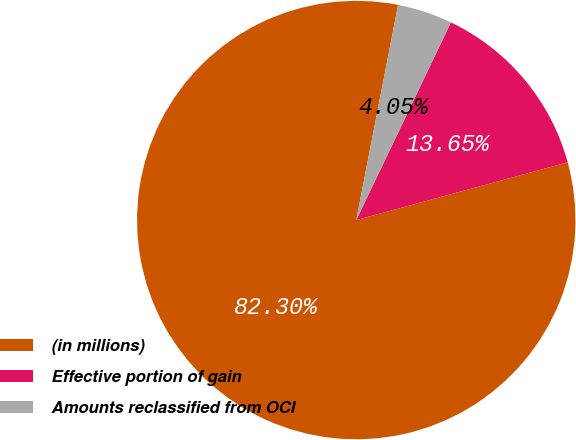Convert chart to OTSL. <chart><loc_0><loc_0><loc_500><loc_500><pie_chart><fcel>(in millions)<fcel>Effective portion of gain<fcel>Amounts reclassified from OCI<nl><fcel>82.3%<fcel>13.65%<fcel>4.05%<nl></chart> 